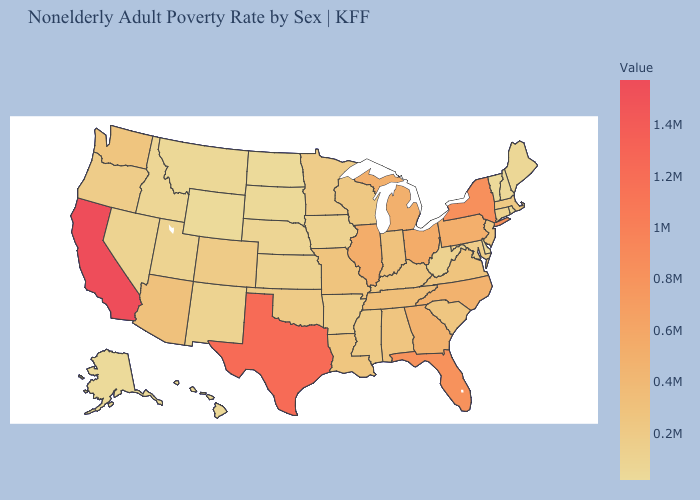Does Nebraska have a lower value than New Jersey?
Concise answer only. Yes. Among the states that border Illinois , does Indiana have the highest value?
Write a very short answer. Yes. Which states have the lowest value in the MidWest?
Write a very short answer. North Dakota. Does Alaska have the lowest value in the USA?
Keep it brief. Yes. Among the states that border Kentucky , does Virginia have the lowest value?
Write a very short answer. No. 